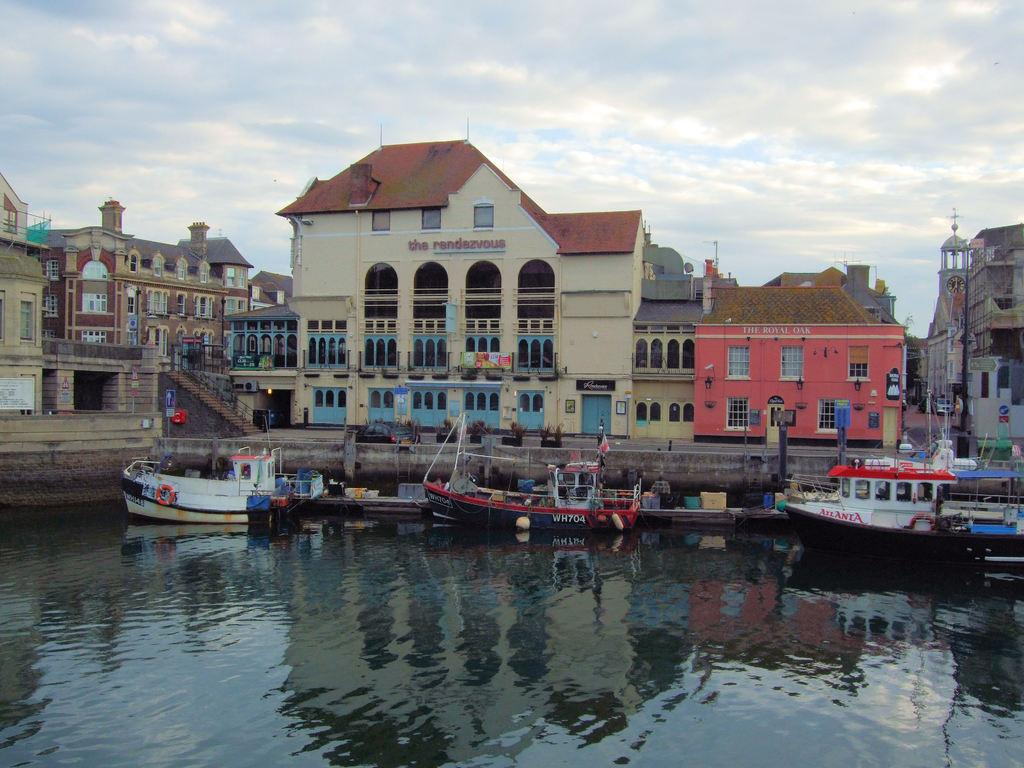Provide a one-sentence caption for the provided image. Boats docked by a building that is named "The Rendezvous". 